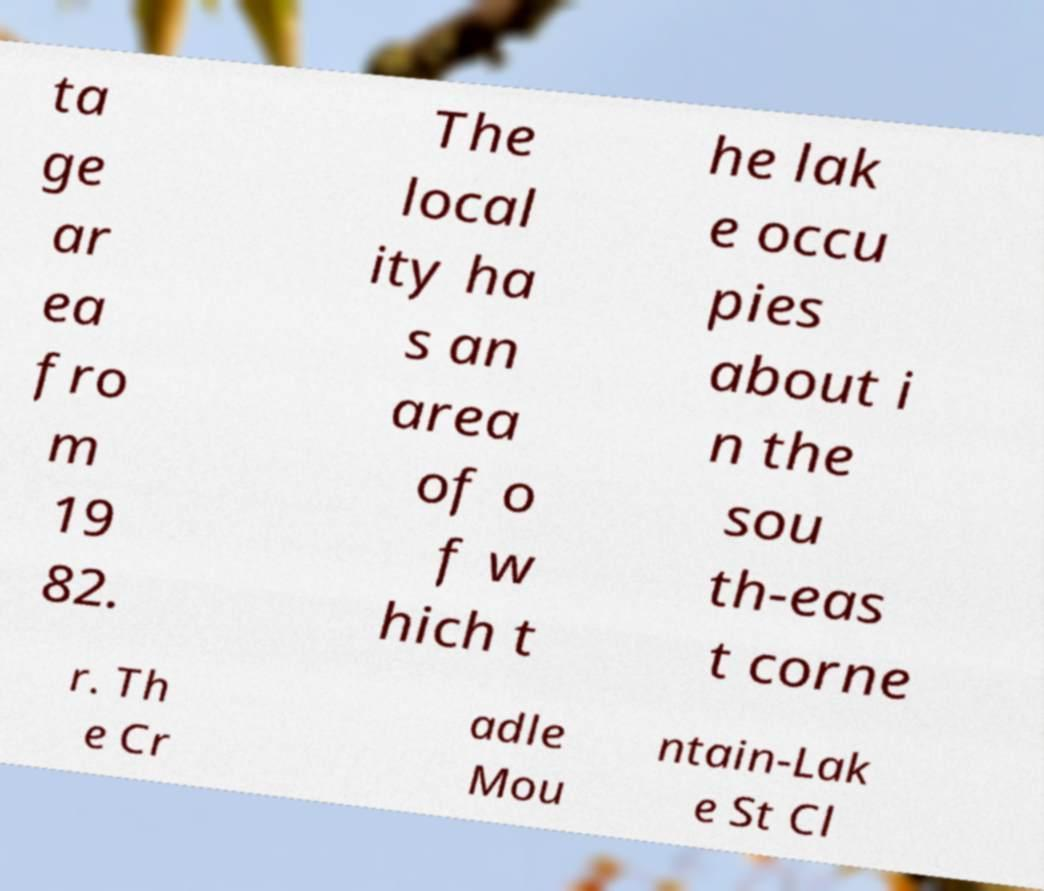What messages or text are displayed in this image? I need them in a readable, typed format. ta ge ar ea fro m 19 82. The local ity ha s an area of o f w hich t he lak e occu pies about i n the sou th-eas t corne r. Th e Cr adle Mou ntain-Lak e St Cl 